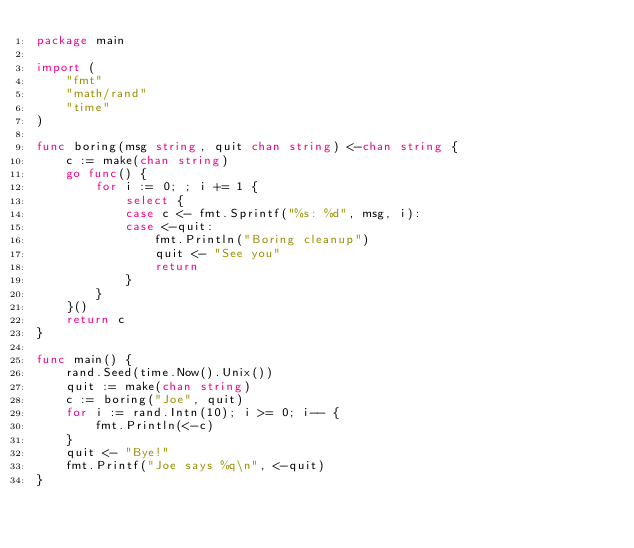Convert code to text. <code><loc_0><loc_0><loc_500><loc_500><_Go_>package main

import (
	"fmt"
	"math/rand"
	"time"
)

func boring(msg string, quit chan string) <-chan string {
	c := make(chan string)
	go func() {
		for i := 0; ; i += 1 {
			select {
			case c <- fmt.Sprintf("%s: %d", msg, i):
			case <-quit:
				fmt.Println("Boring cleanup")
				quit <- "See you"
				return
			}
		}
	}()
	return c
}

func main() {
	rand.Seed(time.Now().Unix())
	quit := make(chan string)
	c := boring("Joe", quit)
	for i := rand.Intn(10); i >= 0; i-- {
		fmt.Println(<-c)
	}
	quit <- "Bye!"
	fmt.Printf("Joe says %q\n", <-quit)
}
</code> 